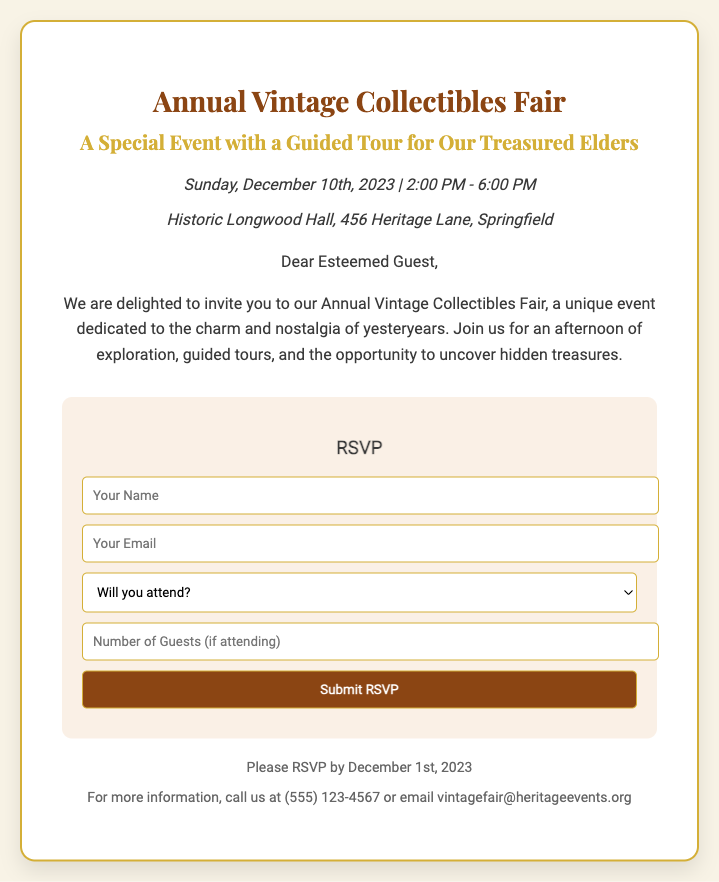What is the date of the event? The date of the event is specified in the document as Sunday, December 10th, 2023.
Answer: December 10th, 2023 What time does the event start? The starting time for the event is given in the document, which is 2:00 PM.
Answer: 2:00 PM Where is the Vintage Collectibles Fair taking place? The location of the event is clearly stated in the document as Historic Longwood Hall, 456 Heritage Lane, Springfield.
Answer: Historic Longwood Hall What is the RSVP deadline? The document mentions that RSVPs should be made by December 1st, 2023.
Answer: December 1st, 2023 What type of event is this? The document highlights that this is an Annual Vintage Collectibles Fair with an emphasis on nostalgia.
Answer: Vintage Collectibles Fair How can I contact the organizers for more information? The contact information for the organizers is provided in the document as a phone number and an email address: (555) 123-4567 or vintagefair@heritageevents.org.
Answer: (555) 123-4567 Will guests be provided with a guided tour? The document specifically states that there will be guided tours as part of the event.
Answer: Yes What is the purpose of this event? The event aims to provide exploration opportunities and to uncover hidden treasures related to vintage collectibles.
Answer: To uncover hidden treasures How many guests can I include in my RSVP? The RSVP form allows the respondent to enter a number for additional guests if attending with them.
Answer: Number of Guests 